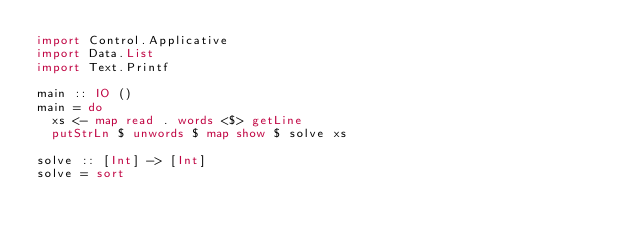Convert code to text. <code><loc_0><loc_0><loc_500><loc_500><_Haskell_>import Control.Applicative
import Data.List
import Text.Printf

main :: IO ()
main = do
  xs <- map read . words <$> getLine
  putStrLn $ unwords $ map show $ solve xs

solve :: [Int] -> [Int]
solve = sort

</code> 